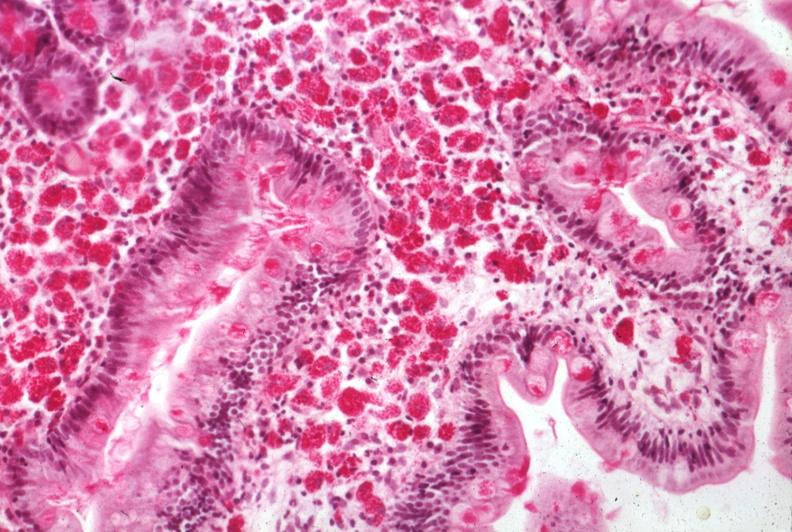what is present?
Answer the question using a single word or phrase. Whipples disease 